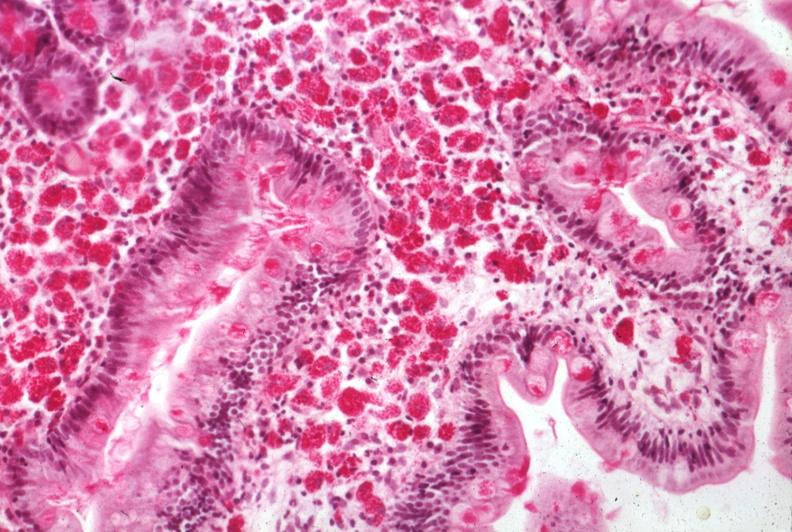what is present?
Answer the question using a single word or phrase. Whipples disease 